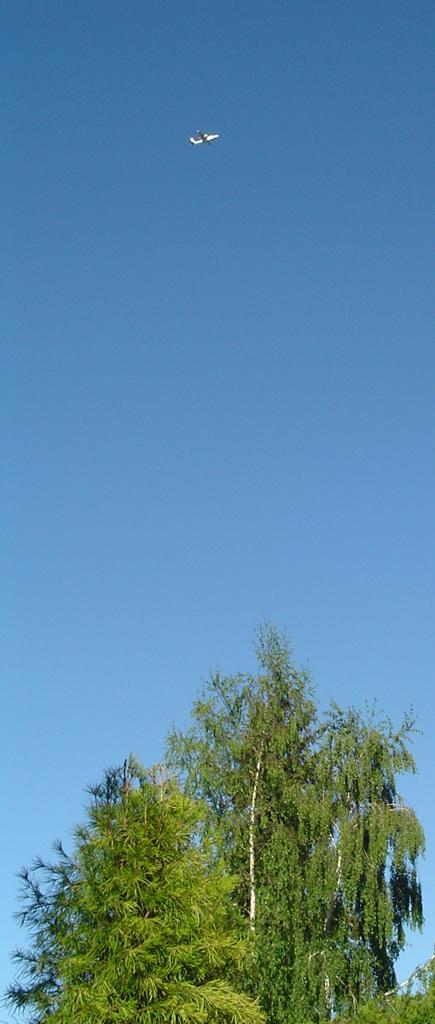In one or two sentences, can you explain what this image depicts? In this image we can see the trees. We can also see the airplane in the air. Sky is also visible in the background. 